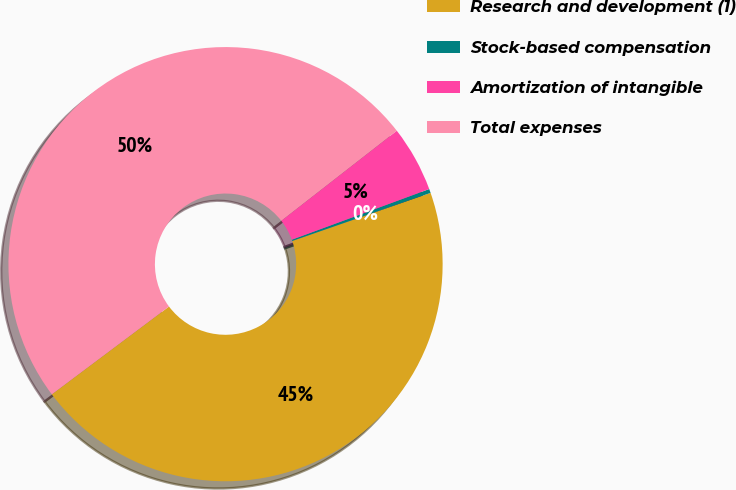Convert chart. <chart><loc_0><loc_0><loc_500><loc_500><pie_chart><fcel>Research and development (1)<fcel>Stock-based compensation<fcel>Amortization of intangible<fcel>Total expenses<nl><fcel>45.09%<fcel>0.3%<fcel>4.91%<fcel>49.7%<nl></chart> 